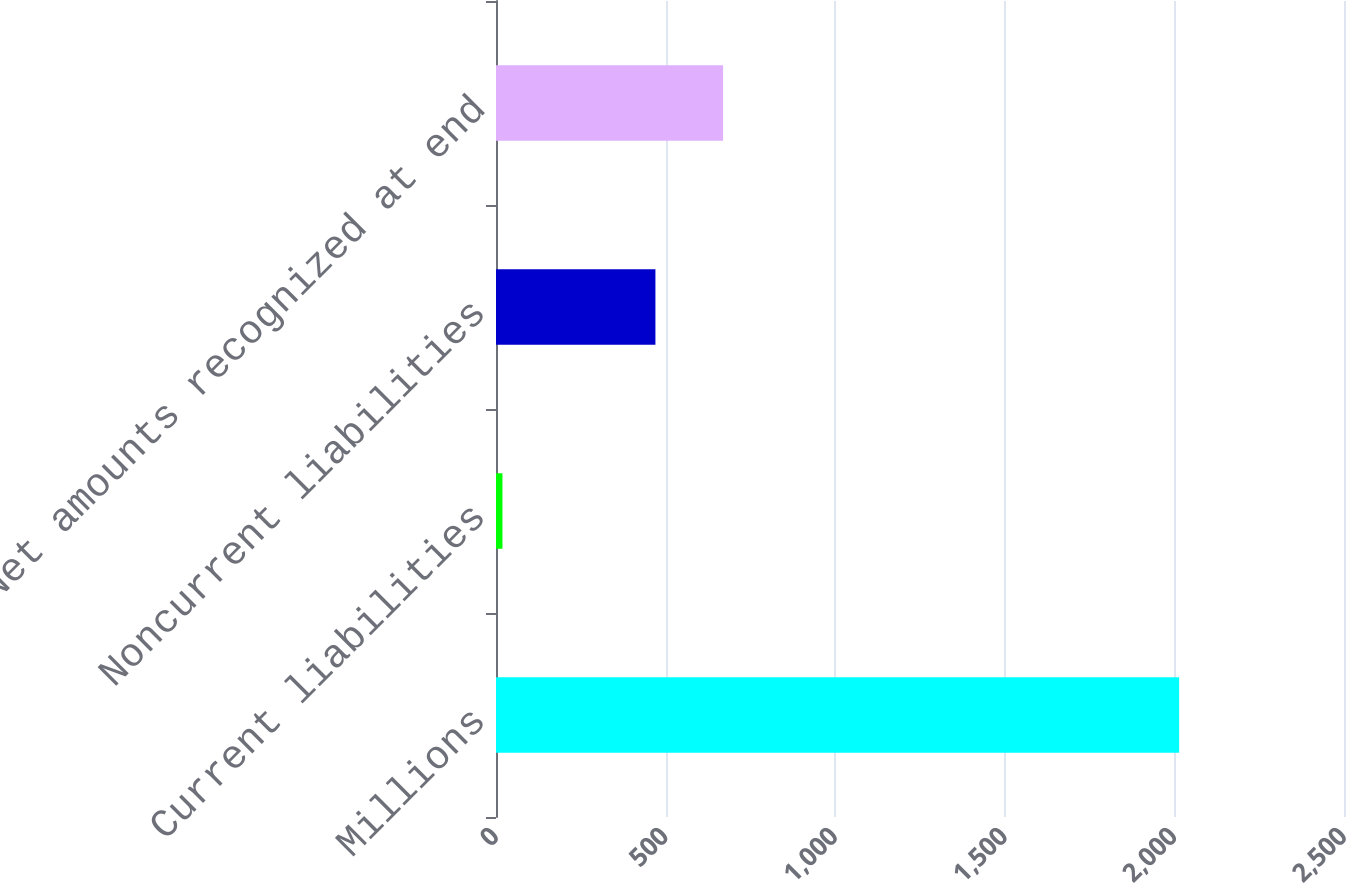Convert chart. <chart><loc_0><loc_0><loc_500><loc_500><bar_chart><fcel>Millions<fcel>Current liabilities<fcel>Noncurrent liabilities<fcel>Net amounts recognized at end<nl><fcel>2014<fcel>19<fcel>470<fcel>669.5<nl></chart> 